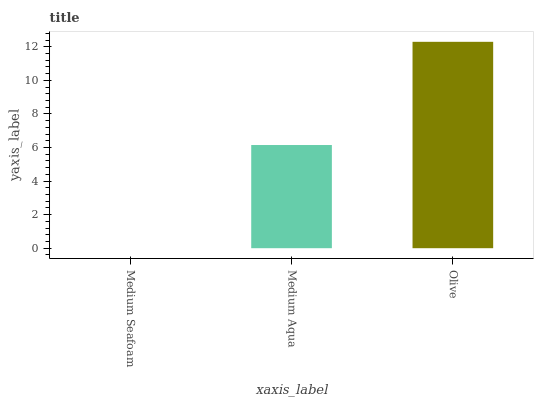Is Medium Aqua the minimum?
Answer yes or no. No. Is Medium Aqua the maximum?
Answer yes or no. No. Is Medium Aqua greater than Medium Seafoam?
Answer yes or no. Yes. Is Medium Seafoam less than Medium Aqua?
Answer yes or no. Yes. Is Medium Seafoam greater than Medium Aqua?
Answer yes or no. No. Is Medium Aqua less than Medium Seafoam?
Answer yes or no. No. Is Medium Aqua the high median?
Answer yes or no. Yes. Is Medium Aqua the low median?
Answer yes or no. Yes. Is Olive the high median?
Answer yes or no. No. Is Olive the low median?
Answer yes or no. No. 